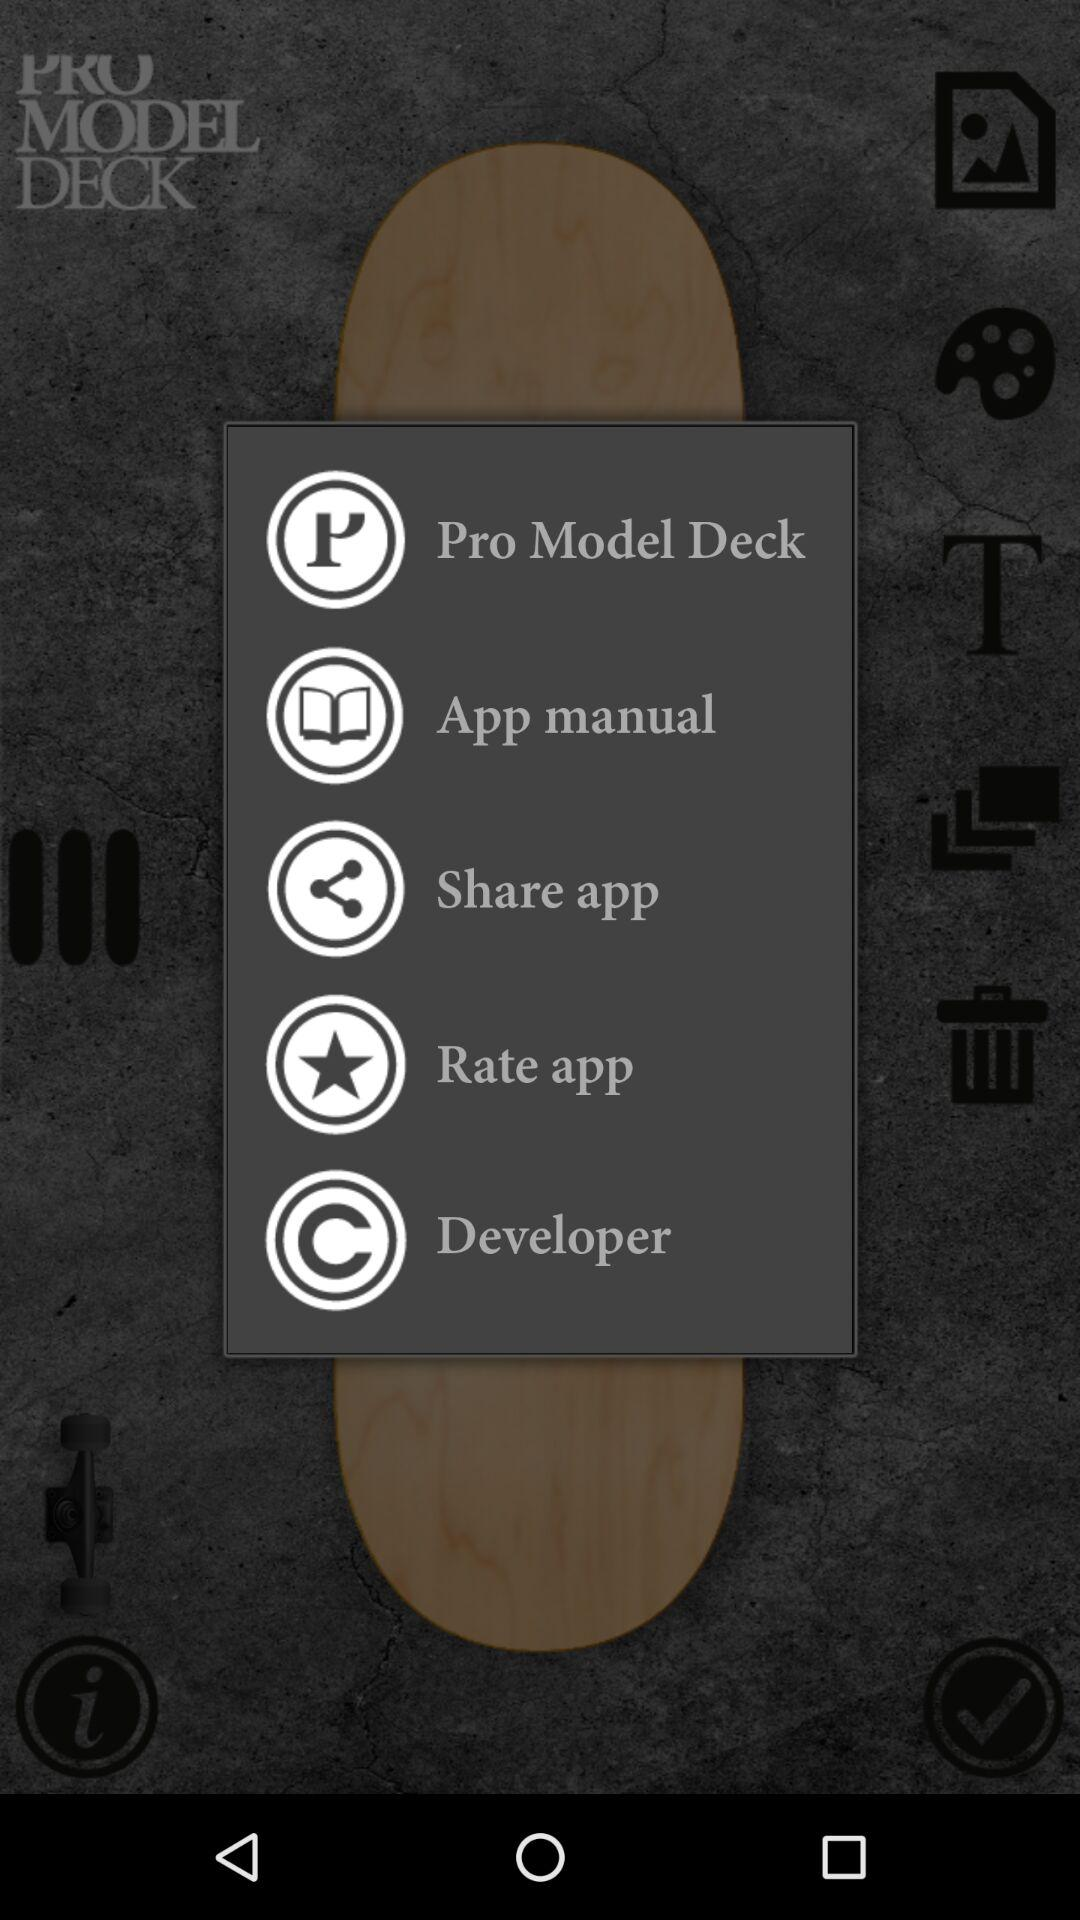What is the application name?
When the provided information is insufficient, respond with <no answer>. <no answer> 